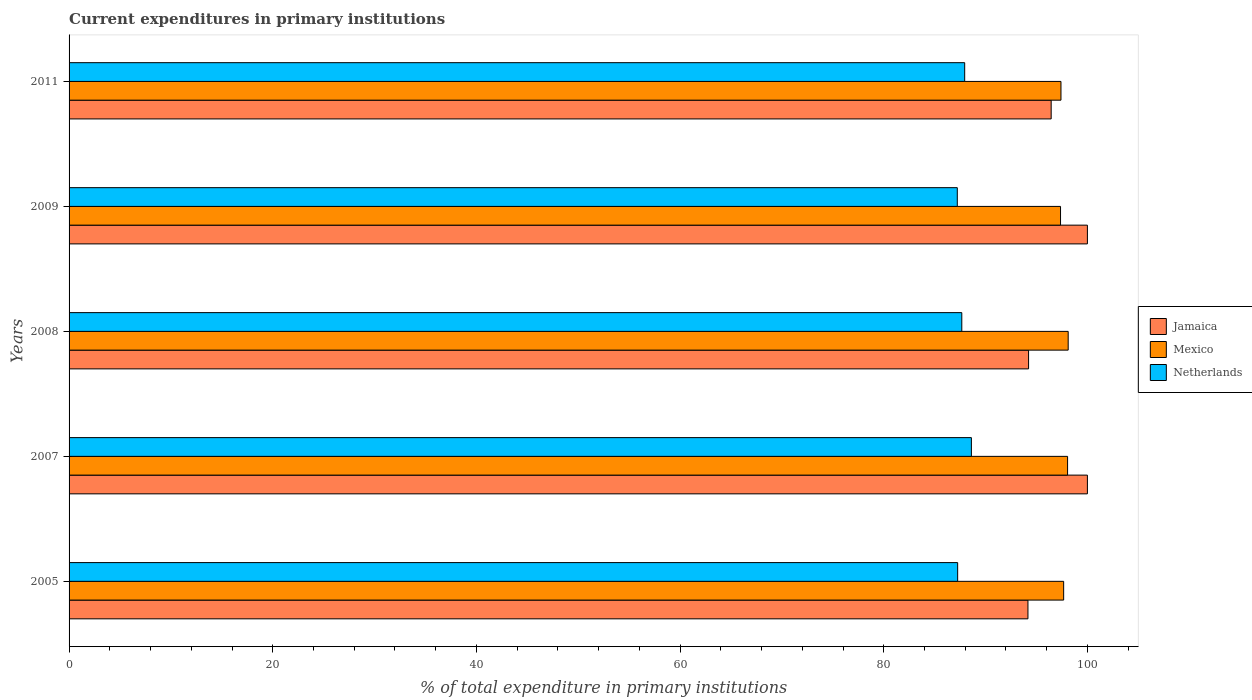How many different coloured bars are there?
Provide a succinct answer. 3. Are the number of bars per tick equal to the number of legend labels?
Offer a very short reply. Yes. How many bars are there on the 4th tick from the top?
Your answer should be compact. 3. What is the current expenditures in primary institutions in Netherlands in 2005?
Your answer should be compact. 87.26. Across all years, what is the maximum current expenditures in primary institutions in Mexico?
Provide a succinct answer. 98.11. Across all years, what is the minimum current expenditures in primary institutions in Netherlands?
Make the answer very short. 87.22. In which year was the current expenditures in primary institutions in Mexico maximum?
Your answer should be compact. 2008. What is the total current expenditures in primary institutions in Netherlands in the graph?
Offer a very short reply. 438.7. What is the difference between the current expenditures in primary institutions in Mexico in 2005 and that in 2008?
Your answer should be compact. -0.45. What is the difference between the current expenditures in primary institutions in Mexico in 2005 and the current expenditures in primary institutions in Jamaica in 2009?
Offer a very short reply. -2.33. What is the average current expenditures in primary institutions in Netherlands per year?
Provide a succinct answer. 87.74. In the year 2008, what is the difference between the current expenditures in primary institutions in Mexico and current expenditures in primary institutions in Netherlands?
Your response must be concise. 10.45. What is the ratio of the current expenditures in primary institutions in Mexico in 2007 to that in 2011?
Your answer should be very brief. 1.01. What is the difference between the highest and the second highest current expenditures in primary institutions in Mexico?
Give a very brief answer. 0.06. What is the difference between the highest and the lowest current expenditures in primary institutions in Jamaica?
Your response must be concise. 5.84. In how many years, is the current expenditures in primary institutions in Netherlands greater than the average current expenditures in primary institutions in Netherlands taken over all years?
Provide a succinct answer. 2. What does the 3rd bar from the top in 2009 represents?
Provide a short and direct response. Jamaica. What does the 1st bar from the bottom in 2011 represents?
Your answer should be very brief. Jamaica. How many bars are there?
Your response must be concise. 15. What is the difference between two consecutive major ticks on the X-axis?
Ensure brevity in your answer.  20. Does the graph contain any zero values?
Offer a very short reply. No. What is the title of the graph?
Ensure brevity in your answer.  Current expenditures in primary institutions. Does "Argentina" appear as one of the legend labels in the graph?
Offer a very short reply. No. What is the label or title of the X-axis?
Ensure brevity in your answer.  % of total expenditure in primary institutions. What is the % of total expenditure in primary institutions in Jamaica in 2005?
Ensure brevity in your answer.  94.16. What is the % of total expenditure in primary institutions of Mexico in 2005?
Give a very brief answer. 97.67. What is the % of total expenditure in primary institutions of Netherlands in 2005?
Keep it short and to the point. 87.26. What is the % of total expenditure in primary institutions of Mexico in 2007?
Give a very brief answer. 98.05. What is the % of total expenditure in primary institutions of Netherlands in 2007?
Your answer should be very brief. 88.61. What is the % of total expenditure in primary institutions in Jamaica in 2008?
Your response must be concise. 94.22. What is the % of total expenditure in primary institutions of Mexico in 2008?
Make the answer very short. 98.11. What is the % of total expenditure in primary institutions of Netherlands in 2008?
Keep it short and to the point. 87.67. What is the % of total expenditure in primary institutions of Mexico in 2009?
Provide a succinct answer. 97.36. What is the % of total expenditure in primary institutions in Netherlands in 2009?
Your response must be concise. 87.22. What is the % of total expenditure in primary institutions in Jamaica in 2011?
Your answer should be compact. 96.44. What is the % of total expenditure in primary institutions of Mexico in 2011?
Give a very brief answer. 97.4. What is the % of total expenditure in primary institutions of Netherlands in 2011?
Make the answer very short. 87.95. Across all years, what is the maximum % of total expenditure in primary institutions of Mexico?
Provide a succinct answer. 98.11. Across all years, what is the maximum % of total expenditure in primary institutions of Netherlands?
Give a very brief answer. 88.61. Across all years, what is the minimum % of total expenditure in primary institutions of Jamaica?
Offer a very short reply. 94.16. Across all years, what is the minimum % of total expenditure in primary institutions of Mexico?
Offer a very short reply. 97.36. Across all years, what is the minimum % of total expenditure in primary institutions in Netherlands?
Provide a succinct answer. 87.22. What is the total % of total expenditure in primary institutions of Jamaica in the graph?
Make the answer very short. 484.83. What is the total % of total expenditure in primary institutions of Mexico in the graph?
Keep it short and to the point. 488.6. What is the total % of total expenditure in primary institutions in Netherlands in the graph?
Your answer should be compact. 438.7. What is the difference between the % of total expenditure in primary institutions in Jamaica in 2005 and that in 2007?
Offer a terse response. -5.84. What is the difference between the % of total expenditure in primary institutions of Mexico in 2005 and that in 2007?
Make the answer very short. -0.39. What is the difference between the % of total expenditure in primary institutions of Netherlands in 2005 and that in 2007?
Keep it short and to the point. -1.35. What is the difference between the % of total expenditure in primary institutions of Jamaica in 2005 and that in 2008?
Offer a terse response. -0.06. What is the difference between the % of total expenditure in primary institutions in Mexico in 2005 and that in 2008?
Ensure brevity in your answer.  -0.45. What is the difference between the % of total expenditure in primary institutions in Netherlands in 2005 and that in 2008?
Offer a terse response. -0.41. What is the difference between the % of total expenditure in primary institutions of Jamaica in 2005 and that in 2009?
Ensure brevity in your answer.  -5.84. What is the difference between the % of total expenditure in primary institutions of Mexico in 2005 and that in 2009?
Your response must be concise. 0.31. What is the difference between the % of total expenditure in primary institutions of Netherlands in 2005 and that in 2009?
Keep it short and to the point. 0.04. What is the difference between the % of total expenditure in primary institutions in Jamaica in 2005 and that in 2011?
Your answer should be very brief. -2.28. What is the difference between the % of total expenditure in primary institutions of Mexico in 2005 and that in 2011?
Your answer should be compact. 0.26. What is the difference between the % of total expenditure in primary institutions of Netherlands in 2005 and that in 2011?
Ensure brevity in your answer.  -0.69. What is the difference between the % of total expenditure in primary institutions of Jamaica in 2007 and that in 2008?
Your answer should be compact. 5.78. What is the difference between the % of total expenditure in primary institutions in Mexico in 2007 and that in 2008?
Your answer should be very brief. -0.06. What is the difference between the % of total expenditure in primary institutions of Netherlands in 2007 and that in 2008?
Make the answer very short. 0.94. What is the difference between the % of total expenditure in primary institutions in Mexico in 2007 and that in 2009?
Your response must be concise. 0.69. What is the difference between the % of total expenditure in primary institutions in Netherlands in 2007 and that in 2009?
Offer a very short reply. 1.38. What is the difference between the % of total expenditure in primary institutions in Jamaica in 2007 and that in 2011?
Your response must be concise. 3.56. What is the difference between the % of total expenditure in primary institutions of Mexico in 2007 and that in 2011?
Offer a very short reply. 0.65. What is the difference between the % of total expenditure in primary institutions of Netherlands in 2007 and that in 2011?
Your response must be concise. 0.66. What is the difference between the % of total expenditure in primary institutions in Jamaica in 2008 and that in 2009?
Make the answer very short. -5.78. What is the difference between the % of total expenditure in primary institutions in Mexico in 2008 and that in 2009?
Provide a succinct answer. 0.75. What is the difference between the % of total expenditure in primary institutions in Netherlands in 2008 and that in 2009?
Your answer should be very brief. 0.44. What is the difference between the % of total expenditure in primary institutions of Jamaica in 2008 and that in 2011?
Provide a succinct answer. -2.22. What is the difference between the % of total expenditure in primary institutions of Mexico in 2008 and that in 2011?
Give a very brief answer. 0.71. What is the difference between the % of total expenditure in primary institutions of Netherlands in 2008 and that in 2011?
Your answer should be compact. -0.28. What is the difference between the % of total expenditure in primary institutions of Jamaica in 2009 and that in 2011?
Provide a short and direct response. 3.56. What is the difference between the % of total expenditure in primary institutions in Mexico in 2009 and that in 2011?
Provide a short and direct response. -0.04. What is the difference between the % of total expenditure in primary institutions of Netherlands in 2009 and that in 2011?
Offer a very short reply. -0.73. What is the difference between the % of total expenditure in primary institutions in Jamaica in 2005 and the % of total expenditure in primary institutions in Mexico in 2007?
Provide a succinct answer. -3.89. What is the difference between the % of total expenditure in primary institutions in Jamaica in 2005 and the % of total expenditure in primary institutions in Netherlands in 2007?
Keep it short and to the point. 5.55. What is the difference between the % of total expenditure in primary institutions of Mexico in 2005 and the % of total expenditure in primary institutions of Netherlands in 2007?
Keep it short and to the point. 9.06. What is the difference between the % of total expenditure in primary institutions in Jamaica in 2005 and the % of total expenditure in primary institutions in Mexico in 2008?
Offer a terse response. -3.95. What is the difference between the % of total expenditure in primary institutions in Jamaica in 2005 and the % of total expenditure in primary institutions in Netherlands in 2008?
Your response must be concise. 6.5. What is the difference between the % of total expenditure in primary institutions of Mexico in 2005 and the % of total expenditure in primary institutions of Netherlands in 2008?
Offer a very short reply. 10. What is the difference between the % of total expenditure in primary institutions in Jamaica in 2005 and the % of total expenditure in primary institutions in Mexico in 2009?
Make the answer very short. -3.2. What is the difference between the % of total expenditure in primary institutions of Jamaica in 2005 and the % of total expenditure in primary institutions of Netherlands in 2009?
Provide a succinct answer. 6.94. What is the difference between the % of total expenditure in primary institutions in Mexico in 2005 and the % of total expenditure in primary institutions in Netherlands in 2009?
Make the answer very short. 10.44. What is the difference between the % of total expenditure in primary institutions of Jamaica in 2005 and the % of total expenditure in primary institutions of Mexico in 2011?
Your response must be concise. -3.24. What is the difference between the % of total expenditure in primary institutions in Jamaica in 2005 and the % of total expenditure in primary institutions in Netherlands in 2011?
Offer a very short reply. 6.21. What is the difference between the % of total expenditure in primary institutions of Mexico in 2005 and the % of total expenditure in primary institutions of Netherlands in 2011?
Provide a succinct answer. 9.72. What is the difference between the % of total expenditure in primary institutions in Jamaica in 2007 and the % of total expenditure in primary institutions in Mexico in 2008?
Provide a succinct answer. 1.89. What is the difference between the % of total expenditure in primary institutions in Jamaica in 2007 and the % of total expenditure in primary institutions in Netherlands in 2008?
Your answer should be very brief. 12.33. What is the difference between the % of total expenditure in primary institutions of Mexico in 2007 and the % of total expenditure in primary institutions of Netherlands in 2008?
Your answer should be very brief. 10.39. What is the difference between the % of total expenditure in primary institutions of Jamaica in 2007 and the % of total expenditure in primary institutions of Mexico in 2009?
Keep it short and to the point. 2.64. What is the difference between the % of total expenditure in primary institutions of Jamaica in 2007 and the % of total expenditure in primary institutions of Netherlands in 2009?
Give a very brief answer. 12.78. What is the difference between the % of total expenditure in primary institutions of Mexico in 2007 and the % of total expenditure in primary institutions of Netherlands in 2009?
Offer a terse response. 10.83. What is the difference between the % of total expenditure in primary institutions in Jamaica in 2007 and the % of total expenditure in primary institutions in Mexico in 2011?
Your response must be concise. 2.6. What is the difference between the % of total expenditure in primary institutions in Jamaica in 2007 and the % of total expenditure in primary institutions in Netherlands in 2011?
Ensure brevity in your answer.  12.05. What is the difference between the % of total expenditure in primary institutions in Mexico in 2007 and the % of total expenditure in primary institutions in Netherlands in 2011?
Keep it short and to the point. 10.1. What is the difference between the % of total expenditure in primary institutions of Jamaica in 2008 and the % of total expenditure in primary institutions of Mexico in 2009?
Provide a short and direct response. -3.14. What is the difference between the % of total expenditure in primary institutions in Jamaica in 2008 and the % of total expenditure in primary institutions in Netherlands in 2009?
Ensure brevity in your answer.  7. What is the difference between the % of total expenditure in primary institutions in Mexico in 2008 and the % of total expenditure in primary institutions in Netherlands in 2009?
Your answer should be very brief. 10.89. What is the difference between the % of total expenditure in primary institutions of Jamaica in 2008 and the % of total expenditure in primary institutions of Mexico in 2011?
Offer a very short reply. -3.18. What is the difference between the % of total expenditure in primary institutions of Jamaica in 2008 and the % of total expenditure in primary institutions of Netherlands in 2011?
Make the answer very short. 6.27. What is the difference between the % of total expenditure in primary institutions of Mexico in 2008 and the % of total expenditure in primary institutions of Netherlands in 2011?
Ensure brevity in your answer.  10.16. What is the difference between the % of total expenditure in primary institutions of Jamaica in 2009 and the % of total expenditure in primary institutions of Mexico in 2011?
Provide a succinct answer. 2.6. What is the difference between the % of total expenditure in primary institutions of Jamaica in 2009 and the % of total expenditure in primary institutions of Netherlands in 2011?
Provide a short and direct response. 12.05. What is the difference between the % of total expenditure in primary institutions of Mexico in 2009 and the % of total expenditure in primary institutions of Netherlands in 2011?
Provide a succinct answer. 9.41. What is the average % of total expenditure in primary institutions in Jamaica per year?
Offer a terse response. 96.97. What is the average % of total expenditure in primary institutions in Mexico per year?
Make the answer very short. 97.72. What is the average % of total expenditure in primary institutions in Netherlands per year?
Offer a terse response. 87.74. In the year 2005, what is the difference between the % of total expenditure in primary institutions of Jamaica and % of total expenditure in primary institutions of Mexico?
Your response must be concise. -3.51. In the year 2005, what is the difference between the % of total expenditure in primary institutions in Jamaica and % of total expenditure in primary institutions in Netherlands?
Offer a very short reply. 6.9. In the year 2005, what is the difference between the % of total expenditure in primary institutions in Mexico and % of total expenditure in primary institutions in Netherlands?
Your answer should be very brief. 10.41. In the year 2007, what is the difference between the % of total expenditure in primary institutions in Jamaica and % of total expenditure in primary institutions in Mexico?
Provide a short and direct response. 1.95. In the year 2007, what is the difference between the % of total expenditure in primary institutions in Jamaica and % of total expenditure in primary institutions in Netherlands?
Give a very brief answer. 11.39. In the year 2007, what is the difference between the % of total expenditure in primary institutions in Mexico and % of total expenditure in primary institutions in Netherlands?
Offer a very short reply. 9.45. In the year 2008, what is the difference between the % of total expenditure in primary institutions of Jamaica and % of total expenditure in primary institutions of Mexico?
Give a very brief answer. -3.89. In the year 2008, what is the difference between the % of total expenditure in primary institutions in Jamaica and % of total expenditure in primary institutions in Netherlands?
Provide a short and direct response. 6.56. In the year 2008, what is the difference between the % of total expenditure in primary institutions of Mexico and % of total expenditure in primary institutions of Netherlands?
Your response must be concise. 10.45. In the year 2009, what is the difference between the % of total expenditure in primary institutions in Jamaica and % of total expenditure in primary institutions in Mexico?
Give a very brief answer. 2.64. In the year 2009, what is the difference between the % of total expenditure in primary institutions of Jamaica and % of total expenditure in primary institutions of Netherlands?
Your response must be concise. 12.78. In the year 2009, what is the difference between the % of total expenditure in primary institutions of Mexico and % of total expenditure in primary institutions of Netherlands?
Provide a succinct answer. 10.14. In the year 2011, what is the difference between the % of total expenditure in primary institutions in Jamaica and % of total expenditure in primary institutions in Mexico?
Your answer should be very brief. -0.96. In the year 2011, what is the difference between the % of total expenditure in primary institutions in Jamaica and % of total expenditure in primary institutions in Netherlands?
Provide a succinct answer. 8.49. In the year 2011, what is the difference between the % of total expenditure in primary institutions in Mexico and % of total expenditure in primary institutions in Netherlands?
Your answer should be compact. 9.45. What is the ratio of the % of total expenditure in primary institutions of Jamaica in 2005 to that in 2007?
Ensure brevity in your answer.  0.94. What is the ratio of the % of total expenditure in primary institutions of Mexico in 2005 to that in 2007?
Provide a succinct answer. 1. What is the ratio of the % of total expenditure in primary institutions of Netherlands in 2005 to that in 2007?
Offer a very short reply. 0.98. What is the ratio of the % of total expenditure in primary institutions in Mexico in 2005 to that in 2008?
Offer a terse response. 1. What is the ratio of the % of total expenditure in primary institutions in Netherlands in 2005 to that in 2008?
Make the answer very short. 1. What is the ratio of the % of total expenditure in primary institutions in Jamaica in 2005 to that in 2009?
Offer a very short reply. 0.94. What is the ratio of the % of total expenditure in primary institutions in Mexico in 2005 to that in 2009?
Keep it short and to the point. 1. What is the ratio of the % of total expenditure in primary institutions of Jamaica in 2005 to that in 2011?
Offer a terse response. 0.98. What is the ratio of the % of total expenditure in primary institutions in Mexico in 2005 to that in 2011?
Offer a very short reply. 1. What is the ratio of the % of total expenditure in primary institutions of Jamaica in 2007 to that in 2008?
Ensure brevity in your answer.  1.06. What is the ratio of the % of total expenditure in primary institutions of Mexico in 2007 to that in 2008?
Ensure brevity in your answer.  1. What is the ratio of the % of total expenditure in primary institutions in Netherlands in 2007 to that in 2008?
Provide a succinct answer. 1.01. What is the ratio of the % of total expenditure in primary institutions in Jamaica in 2007 to that in 2009?
Ensure brevity in your answer.  1. What is the ratio of the % of total expenditure in primary institutions of Mexico in 2007 to that in 2009?
Offer a very short reply. 1.01. What is the ratio of the % of total expenditure in primary institutions of Netherlands in 2007 to that in 2009?
Offer a terse response. 1.02. What is the ratio of the % of total expenditure in primary institutions in Jamaica in 2007 to that in 2011?
Keep it short and to the point. 1.04. What is the ratio of the % of total expenditure in primary institutions in Mexico in 2007 to that in 2011?
Make the answer very short. 1.01. What is the ratio of the % of total expenditure in primary institutions in Netherlands in 2007 to that in 2011?
Offer a terse response. 1.01. What is the ratio of the % of total expenditure in primary institutions in Jamaica in 2008 to that in 2009?
Ensure brevity in your answer.  0.94. What is the ratio of the % of total expenditure in primary institutions in Mexico in 2008 to that in 2009?
Keep it short and to the point. 1.01. What is the ratio of the % of total expenditure in primary institutions of Jamaica in 2008 to that in 2011?
Offer a terse response. 0.98. What is the ratio of the % of total expenditure in primary institutions in Mexico in 2008 to that in 2011?
Provide a succinct answer. 1.01. What is the ratio of the % of total expenditure in primary institutions of Netherlands in 2008 to that in 2011?
Give a very brief answer. 1. What is the ratio of the % of total expenditure in primary institutions in Jamaica in 2009 to that in 2011?
Offer a terse response. 1.04. What is the ratio of the % of total expenditure in primary institutions of Mexico in 2009 to that in 2011?
Keep it short and to the point. 1. What is the difference between the highest and the second highest % of total expenditure in primary institutions of Mexico?
Offer a very short reply. 0.06. What is the difference between the highest and the second highest % of total expenditure in primary institutions in Netherlands?
Offer a terse response. 0.66. What is the difference between the highest and the lowest % of total expenditure in primary institutions of Jamaica?
Provide a succinct answer. 5.84. What is the difference between the highest and the lowest % of total expenditure in primary institutions of Mexico?
Offer a very short reply. 0.75. What is the difference between the highest and the lowest % of total expenditure in primary institutions of Netherlands?
Offer a very short reply. 1.38. 